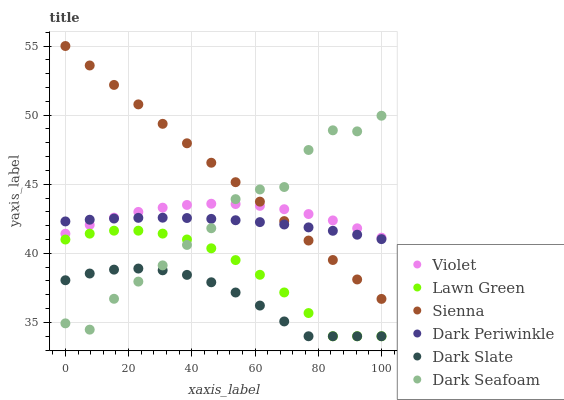Does Dark Slate have the minimum area under the curve?
Answer yes or no. Yes. Does Sienna have the maximum area under the curve?
Answer yes or no. Yes. Does Sienna have the minimum area under the curve?
Answer yes or no. No. Does Dark Slate have the maximum area under the curve?
Answer yes or no. No. Is Sienna the smoothest?
Answer yes or no. Yes. Is Dark Seafoam the roughest?
Answer yes or no. Yes. Is Dark Slate the smoothest?
Answer yes or no. No. Is Dark Slate the roughest?
Answer yes or no. No. Does Lawn Green have the lowest value?
Answer yes or no. Yes. Does Sienna have the lowest value?
Answer yes or no. No. Does Sienna have the highest value?
Answer yes or no. Yes. Does Dark Slate have the highest value?
Answer yes or no. No. Is Lawn Green less than Sienna?
Answer yes or no. Yes. Is Sienna greater than Lawn Green?
Answer yes or no. Yes. Does Lawn Green intersect Dark Seafoam?
Answer yes or no. Yes. Is Lawn Green less than Dark Seafoam?
Answer yes or no. No. Is Lawn Green greater than Dark Seafoam?
Answer yes or no. No. Does Lawn Green intersect Sienna?
Answer yes or no. No. 